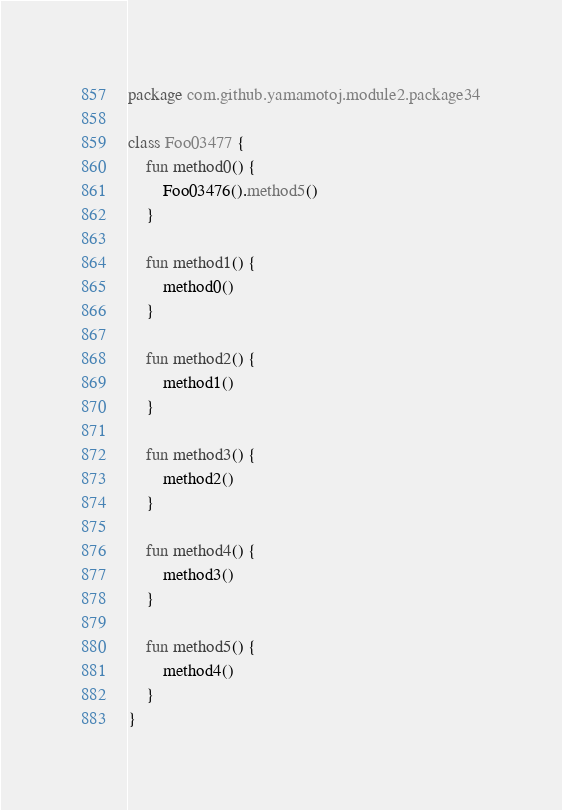<code> <loc_0><loc_0><loc_500><loc_500><_Kotlin_>package com.github.yamamotoj.module2.package34

class Foo03477 {
    fun method0() {
        Foo03476().method5()
    }

    fun method1() {
        method0()
    }

    fun method2() {
        method1()
    }

    fun method3() {
        method2()
    }

    fun method4() {
        method3()
    }

    fun method5() {
        method4()
    }
}
</code> 